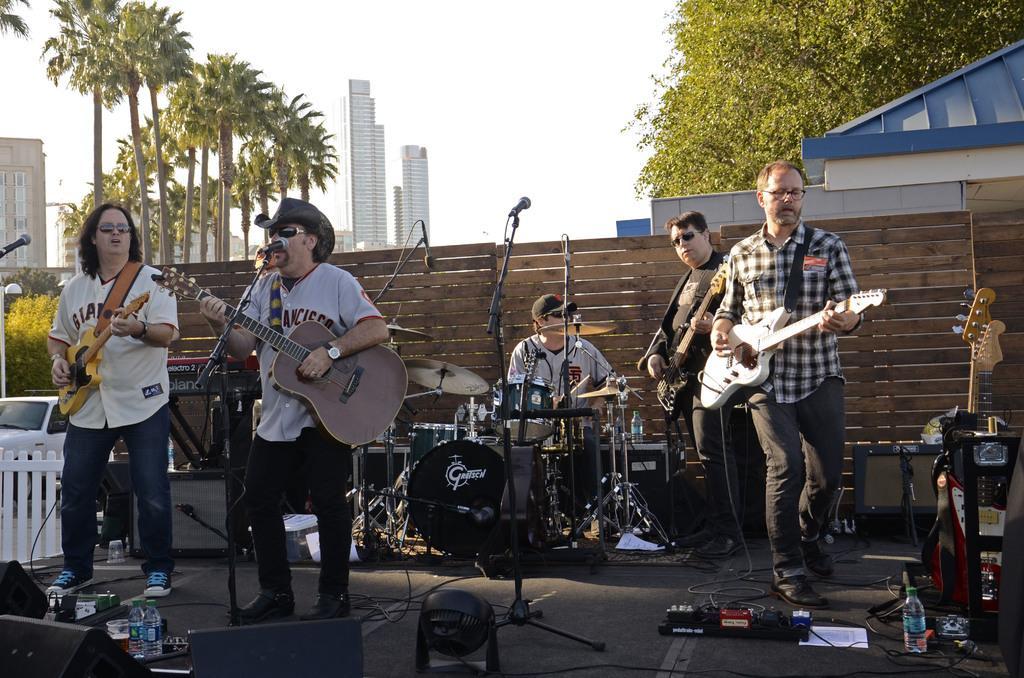Describe this image in one or two sentences. This image is clicked outside. This might be clicked in a musical concert. There are so many people on the stage who are playing musical instruments. There are mikes and there are so many musical instruments in this image. There is a car on the left side and there is a building on the left side. There are trees on the left side and right side. There is sky on the top. 